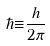Convert formula to latex. <formula><loc_0><loc_0><loc_500><loc_500>\hbar { \equiv } \frac { h } { 2 \pi }</formula> 